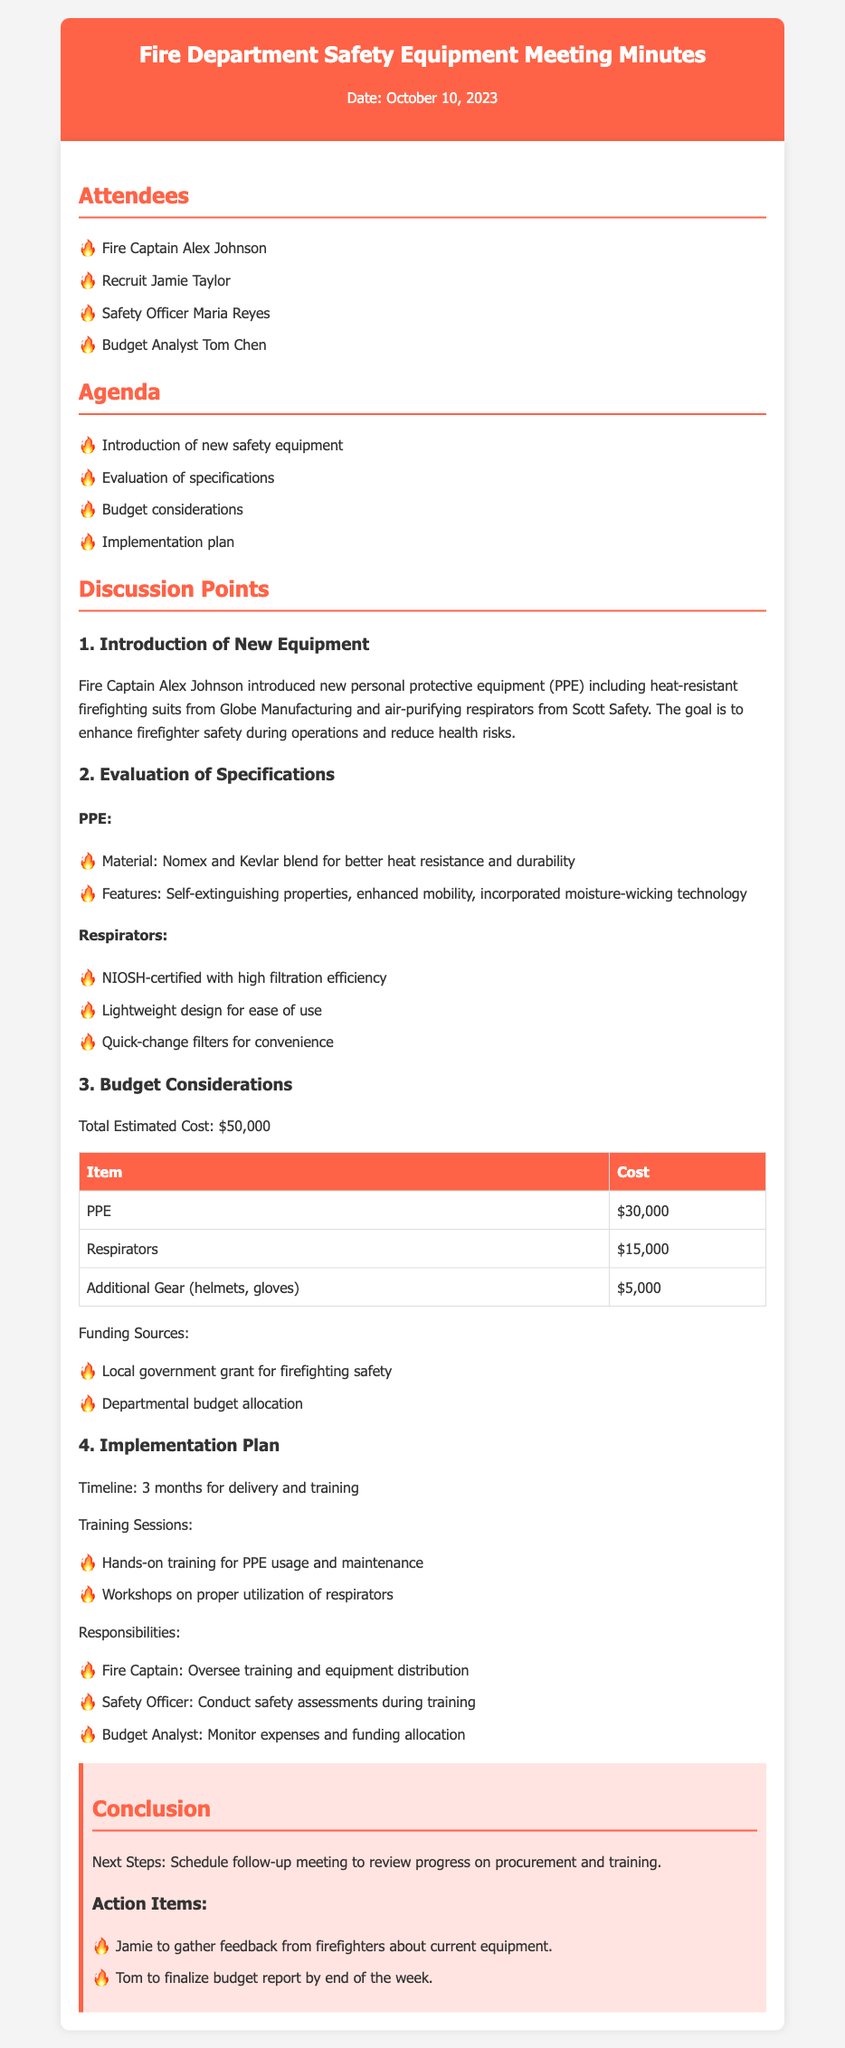What is the date of the meeting? The date of the meeting is mentioned at the beginning of the document as October 10, 2023.
Answer: October 10, 2023 Who introduced the new equipment? The Fire Captain Alex Johnson is noted as the person who introduced the new equipment in the discussion points.
Answer: Alex Johnson What is the total estimated cost for the new safety equipment? The total estimated cost is provided in the budget considerations section and is explicitly stated as $50,000.
Answer: $50,000 What materials are used in the new PPE? The document details the materials used in the PPE as a Nomex and Kevlar blend, enhancing heat resistance and durability.
Answer: Nomex and Kevlar How long is the timeline for delivery and training? The timeline for delivery and training is discussed under the implementation plan, specifically mentioned as 3 months.
Answer: 3 months What are the additional gear costs? The budget table includes a line for additional gear, which amounts to $5,000, thus providing the relevant cost information.
Answer: $5,000 What is one of the funding sources for the equipment? Funding sources are listed, and one of them is a local government grant for firefighting safety, denoting the financial backing.
Answer: Local government grant What training will be conducted for respirators? The document mentions workshops on proper utilization of respirators under the training sessions section, clarifying what training is planned.
Answer: Workshops Who is responsible for monitoring expenses? The budget analyst is designated to monitor expenses and funding allocation, indicating their role in the budgeting process.
Answer: Budget Analyst 